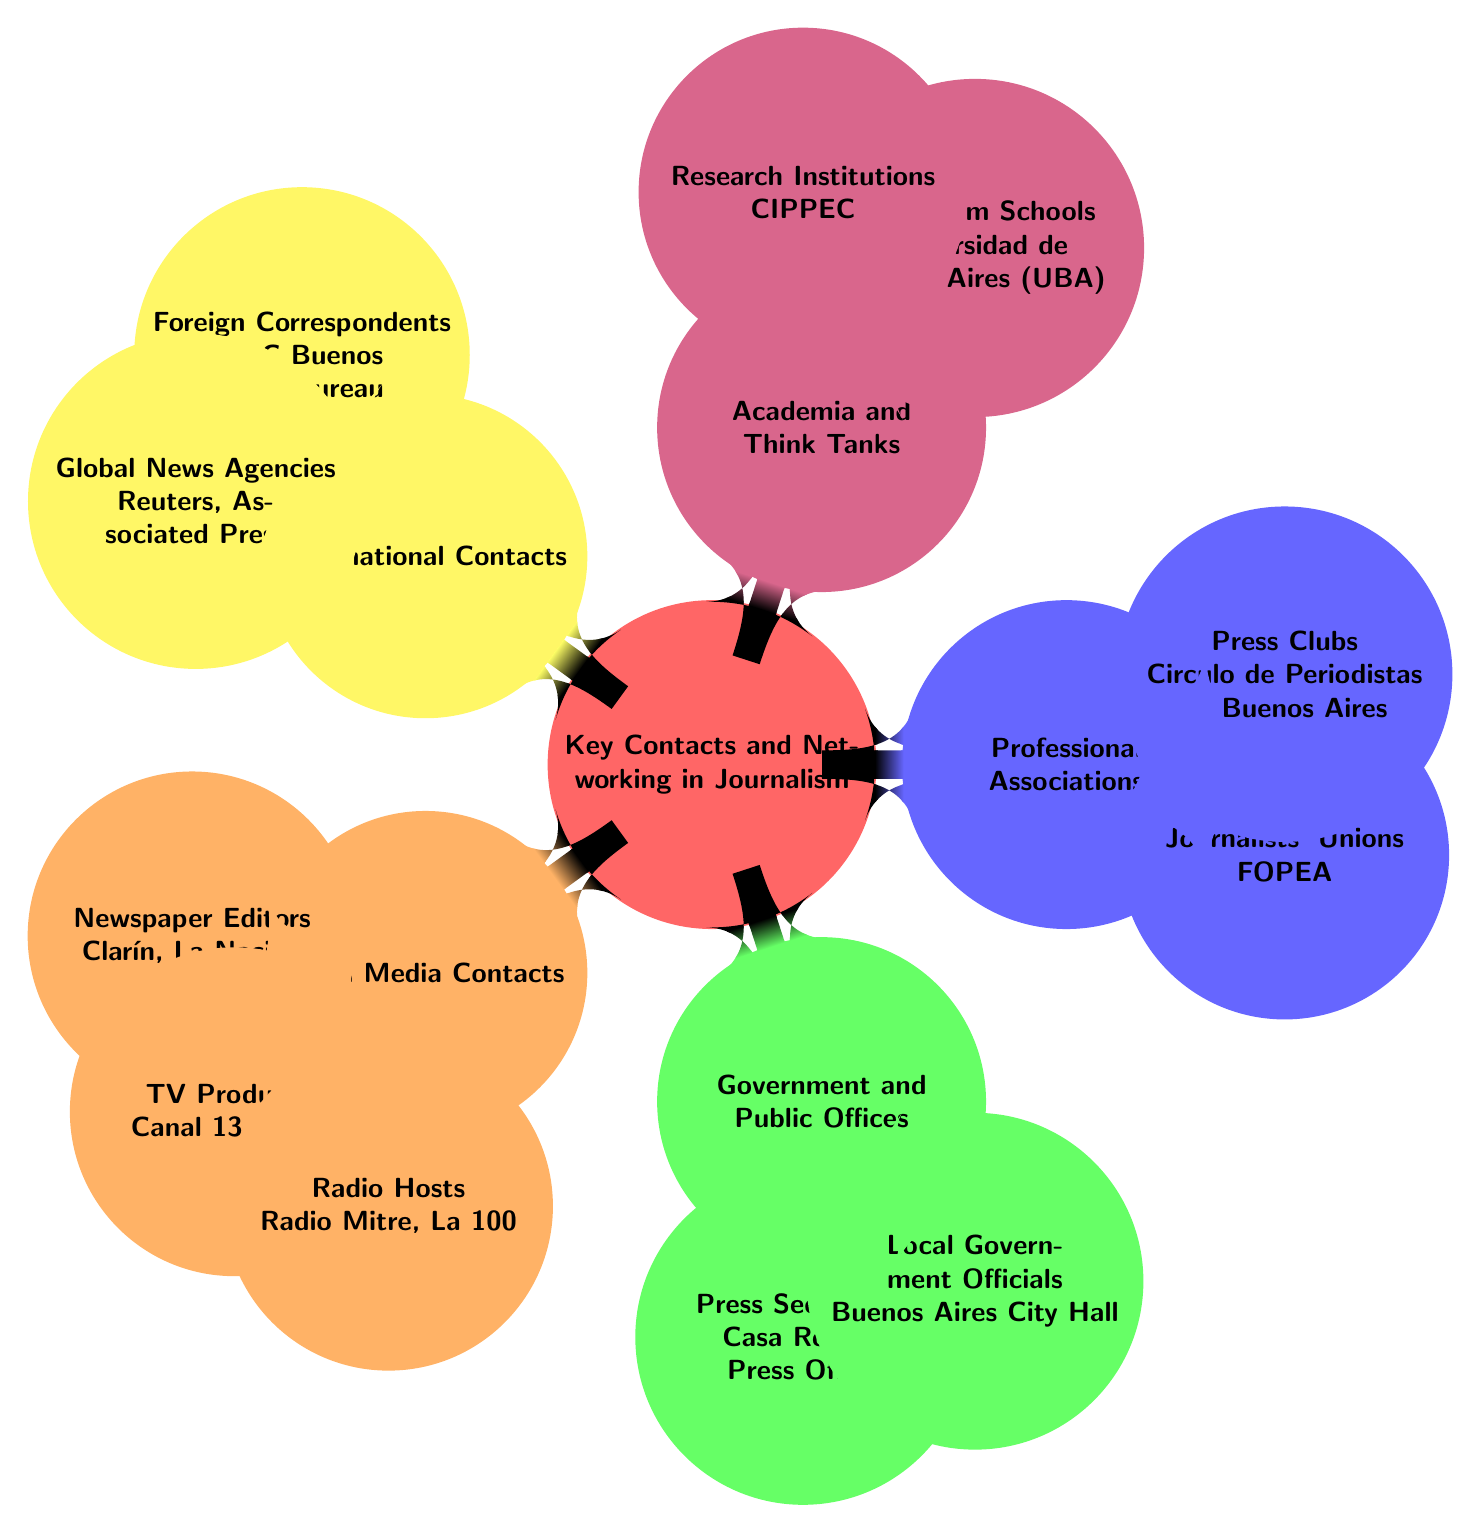What are the two local newspaper editors listed? The diagram explicitly lists two local newspaper editors, which are Clarín and La Nación, under the "Local Media Contacts" section.
Answer: Clarín, La Nación How many types of local media contacts are there? In the "Local Media Contacts" section, three types are listed: Newspaper Editors, TV Producers, and Radio Hosts. Therefore, the count is three.
Answer: 3 Which organization focuses on journalism education in Argentina? The node under "Academia and Think Tanks" dedicated to journalism education is Universidad de Buenos Aires (UBA), indicating its focus on this area.
Answer: Universidad de Buenos Aires (UBA) Which agencies represent international news contacts in the diagram? The "International Contacts" section specifies two types of agencies: Foreign Correspondents, represented by the BBC Buenos Aires Bureau, and Global News Agencies, which include Reuters and Associated Press.
Answer: Reuters, Associated Press What is the relationship between Local Media Contacts and their specific roles? The "Local Media Contacts" node contains sub-nodes that detail specific roles: Newspaper Editors, TV Producers, and Radio Hosts, indicating a hierarchy where Local Media Contacts is the parent category.
Answer: Newspaper Editors, TV Producers, Radio Hosts What type of organization is FOPEA? FOPEA is classified under "Professional Associations" as a Journalist's Union, indicating its role in representing journalists in Argentina.
Answer: Journalists' Unions How many government and public offices are identified in the diagram? The "Government and Public Offices" section lists two types: Press Secretaries and Local Government Officials, making the total count of identified offices two.
Answer: 2 Which media type has contacts from Canal 13, and Telefe? The TV Producers listed under "Local Media Contacts" include Canal 13 and Telefe specifically, indicating their roles as producers in the television sector.
Answer: TV Producers What kind of institutions are represented in the Academia and Think Tanks category? The "Academia and Think Tanks" category comprises Journalism Schools and Research Institutions, indicating a focus on educational and research entities related to journalism.
Answer: Journalism Schools, Research Institutions 